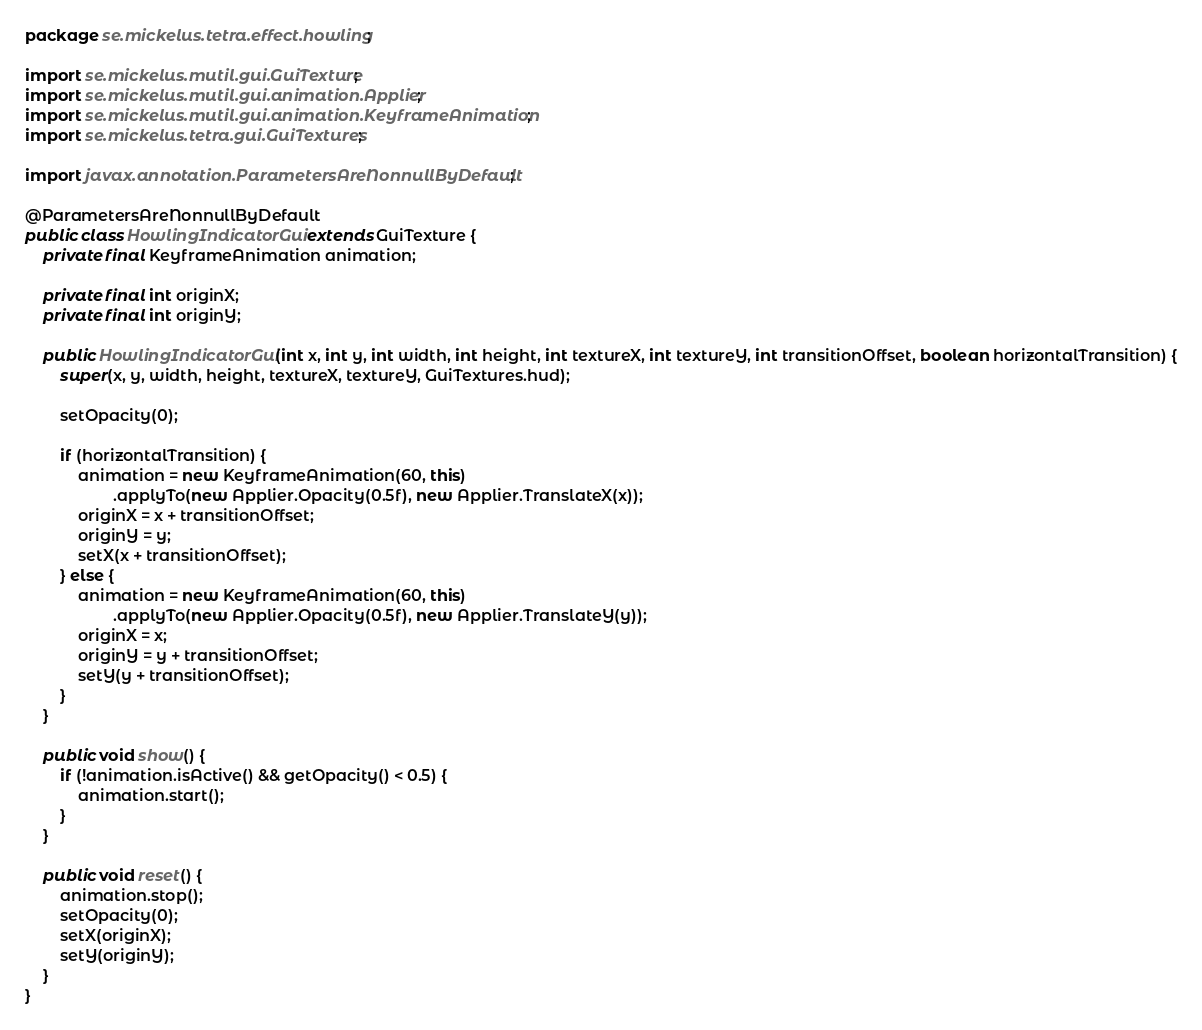Convert code to text. <code><loc_0><loc_0><loc_500><loc_500><_Java_>package se.mickelus.tetra.effect.howling;

import se.mickelus.mutil.gui.GuiTexture;
import se.mickelus.mutil.gui.animation.Applier;
import se.mickelus.mutil.gui.animation.KeyframeAnimation;
import se.mickelus.tetra.gui.GuiTextures;

import javax.annotation.ParametersAreNonnullByDefault;

@ParametersAreNonnullByDefault
public class HowlingIndicatorGui extends GuiTexture {
    private final KeyframeAnimation animation;

    private final int originX;
    private final int originY;

    public HowlingIndicatorGui(int x, int y, int width, int height, int textureX, int textureY, int transitionOffset, boolean horizontalTransition) {
        super(x, y, width, height, textureX, textureY, GuiTextures.hud);

        setOpacity(0);

        if (horizontalTransition) {
            animation = new KeyframeAnimation(60, this)
                    .applyTo(new Applier.Opacity(0.5f), new Applier.TranslateX(x));
            originX = x + transitionOffset;
            originY = y;
            setX(x + transitionOffset);
        } else {
            animation = new KeyframeAnimation(60, this)
                    .applyTo(new Applier.Opacity(0.5f), new Applier.TranslateY(y));
            originX = x;
            originY = y + transitionOffset;
            setY(y + transitionOffset);
        }
    }

    public void show() {
        if (!animation.isActive() && getOpacity() < 0.5) {
            animation.start();
        }
    }

    public void reset() {
        animation.stop();
        setOpacity(0);
        setX(originX);
        setY(originY);
    }
}
</code> 